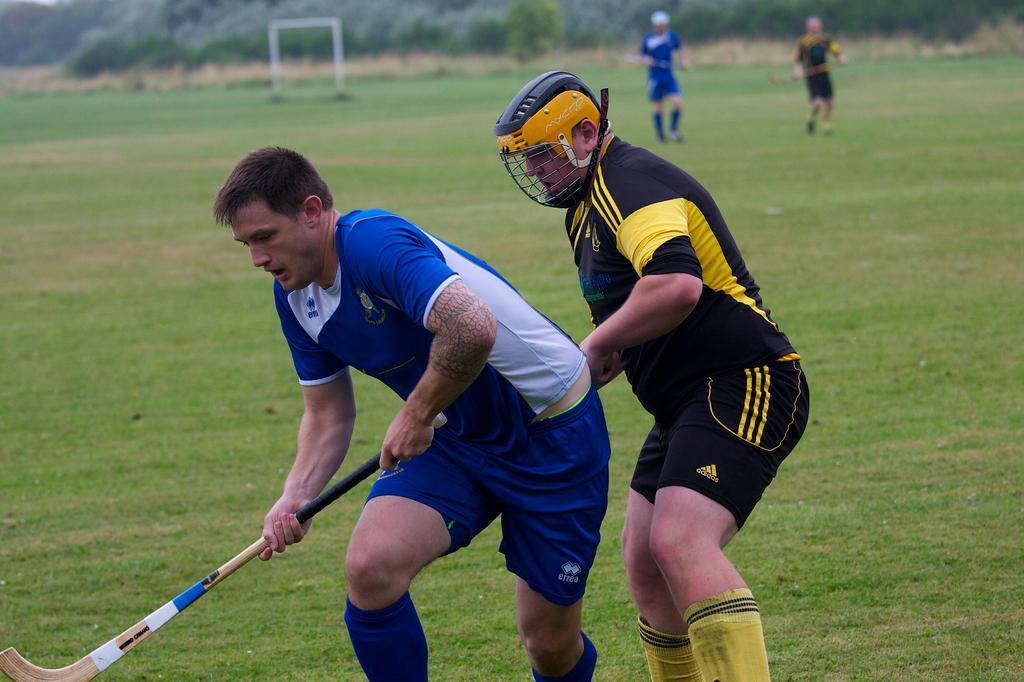In one or two sentences, can you explain what this image depicts? In this image we can see a person holding a hockey stick. Behind him there is a person wearing helmet. On the ground there is grass. In the background there are two persons. Also there is a post. And there are trees. And it is blurry in the background. 